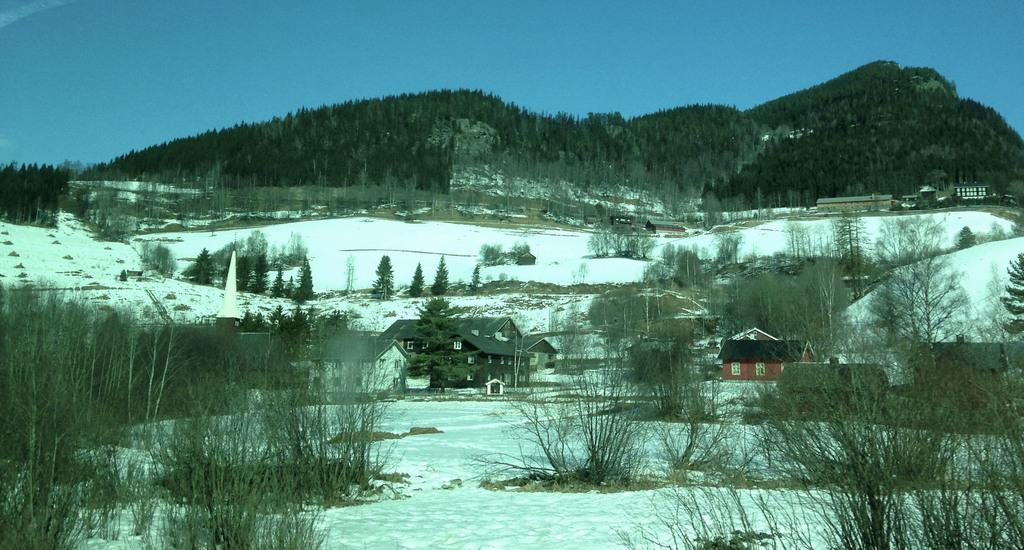What can be seen in the middle of the image? There are houses, trees, plants, and ice in the middle of the image. What is present at the top of the image? There are trees, hills, houses, and the sky visible at the top of the image. What type of paper can be seen on someone's wrist in the image? There is no paper or wrist visible in the image; it only features houses, trees, plants, ice, and the sky. 